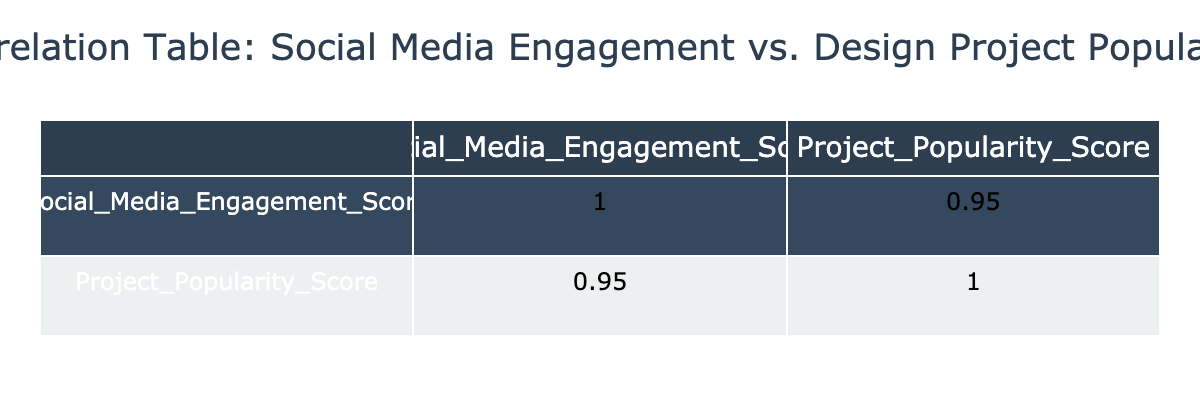What is the Social Media Engagement Score for the "Business Card Redesign for Local Cafe"? The table directly states that the Social Media Engagement Score for the "Business Card Redesign for Local Cafe" project is 65.
Answer: 65 What is the Project Popularity Score for "Infographic on Climate Change"? According to the table, the Project Popularity Score for "Infographic on Climate Change" is 90.
Answer: 90 Is the Project Popularity Score higher for the "Logo Design for EcoBrand" than for the "Charity Event Flyer"? The Project Popularity Score for "Logo Design for EcoBrand" is 92, while for the "Charity Event Flyer" it is 70. Since 92 is greater than 70, the statement is true.
Answer: Yes What is the average Social Media Engagement Score for all projects listed? To find the average, first sum the Social Media Engagement Scores: (85 + 78 + 95 + 72 + 68 + 82 + 65 + 90 + 92 + 88) = 830. There are 10 projects, so the average is 830 / 10 = 83.
Answer: 83 Which project has the highest Project Popularity Score? The table lists "Brand Identity for Tech Startup" with a Project Popularity Score of 97, which is the highest among all projects thus making it the answer.
Answer: Brand Identity for Tech Startup What is the difference between the highest and lowest Social Media Engagement Scores? The highest Social Media Engagement Score is 95 ("Social Media Campaign for FashionWeek"), and the lowest is 65 ("Business Card Redesign for Local Cafe"). The difference is 95 - 65 = 30.
Answer: 30 Is the correlation between Social Media Engagement Score and Project Popularity Score positive? Since a correlation value would typically be above 0, a positive correlation indicates that as one score increases, the other also tends to increase. Based on the scores presented, this seems true as higher engagement generally leads to higher popularity.
Answer: Yes Which project has both a Social Media Engagement Score and Project Popularity Score above 90? From the data, the projects that meet both criteria are "Social Media Campaign for FashionWeek" (95, 95) and "Brand Identity for Tech Startup" (92, 97).
Answer: Social Media Campaign for FashionWeek, Brand Identity for Tech Startup 